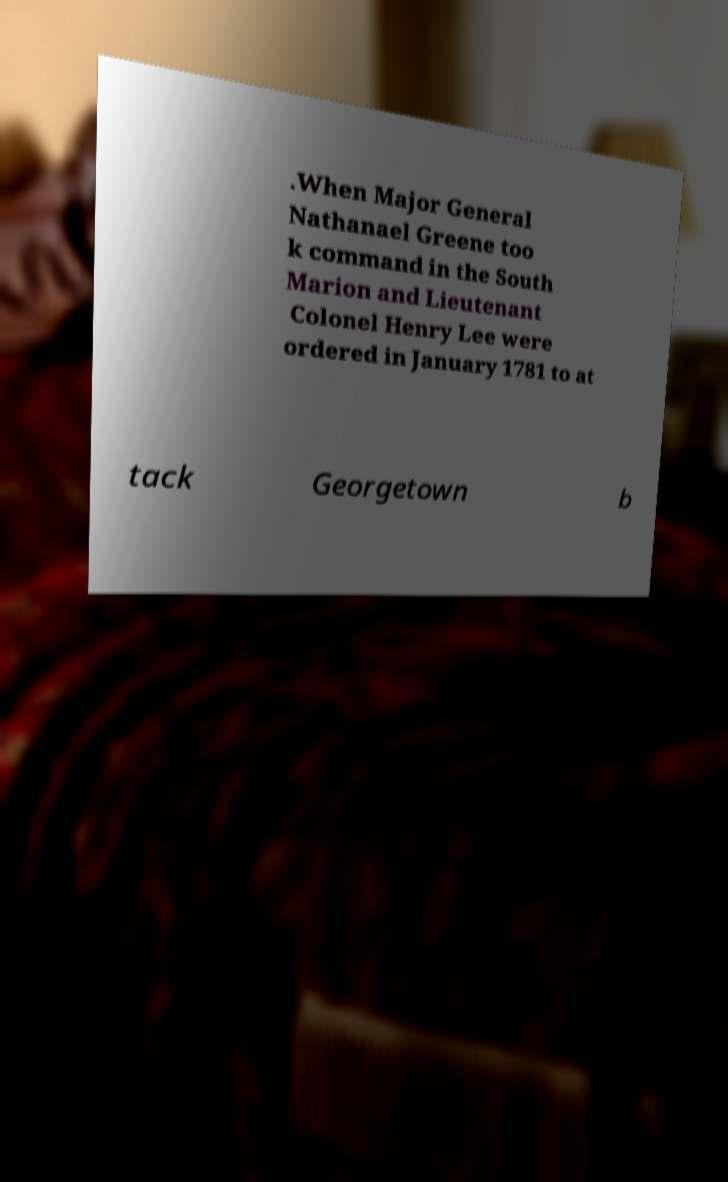Can you accurately transcribe the text from the provided image for me? .When Major General Nathanael Greene too k command in the South Marion and Lieutenant Colonel Henry Lee were ordered in January 1781 to at tack Georgetown b 